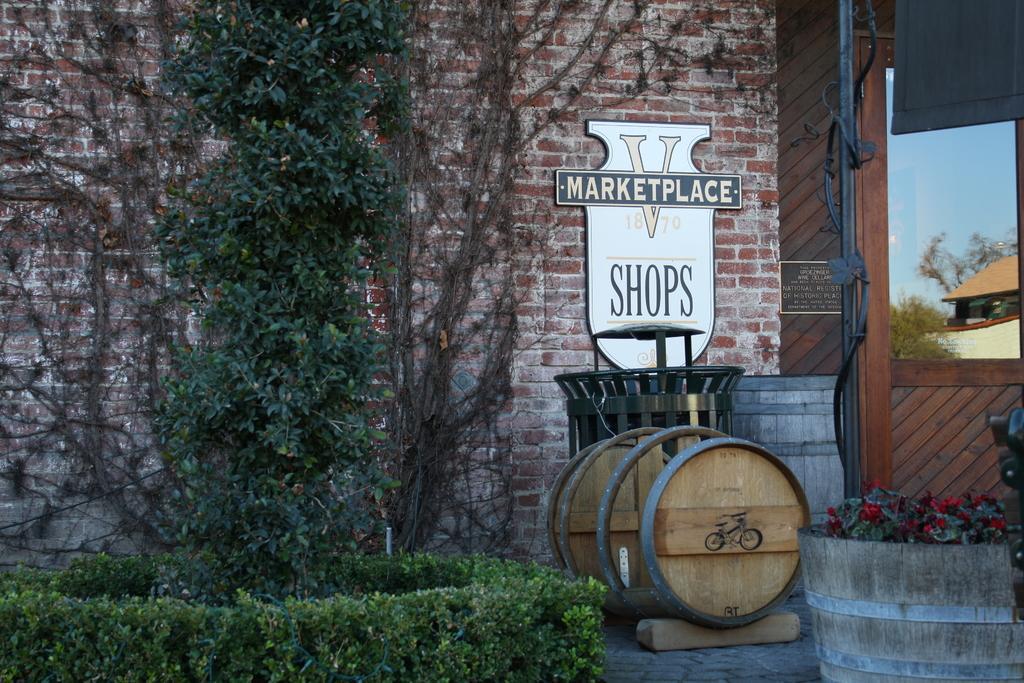Please provide a concise description of this image. This image is taken outdoors. At the bottom of the image there is a floor and there are a few plants. On the right side of the image there is a pot with a plant in it. In the background there is a building and there is a board with a text on it and there is a picture frame on it. On the left side of the image there is a tree. In the middle of the image there is a barrel on the floor. 